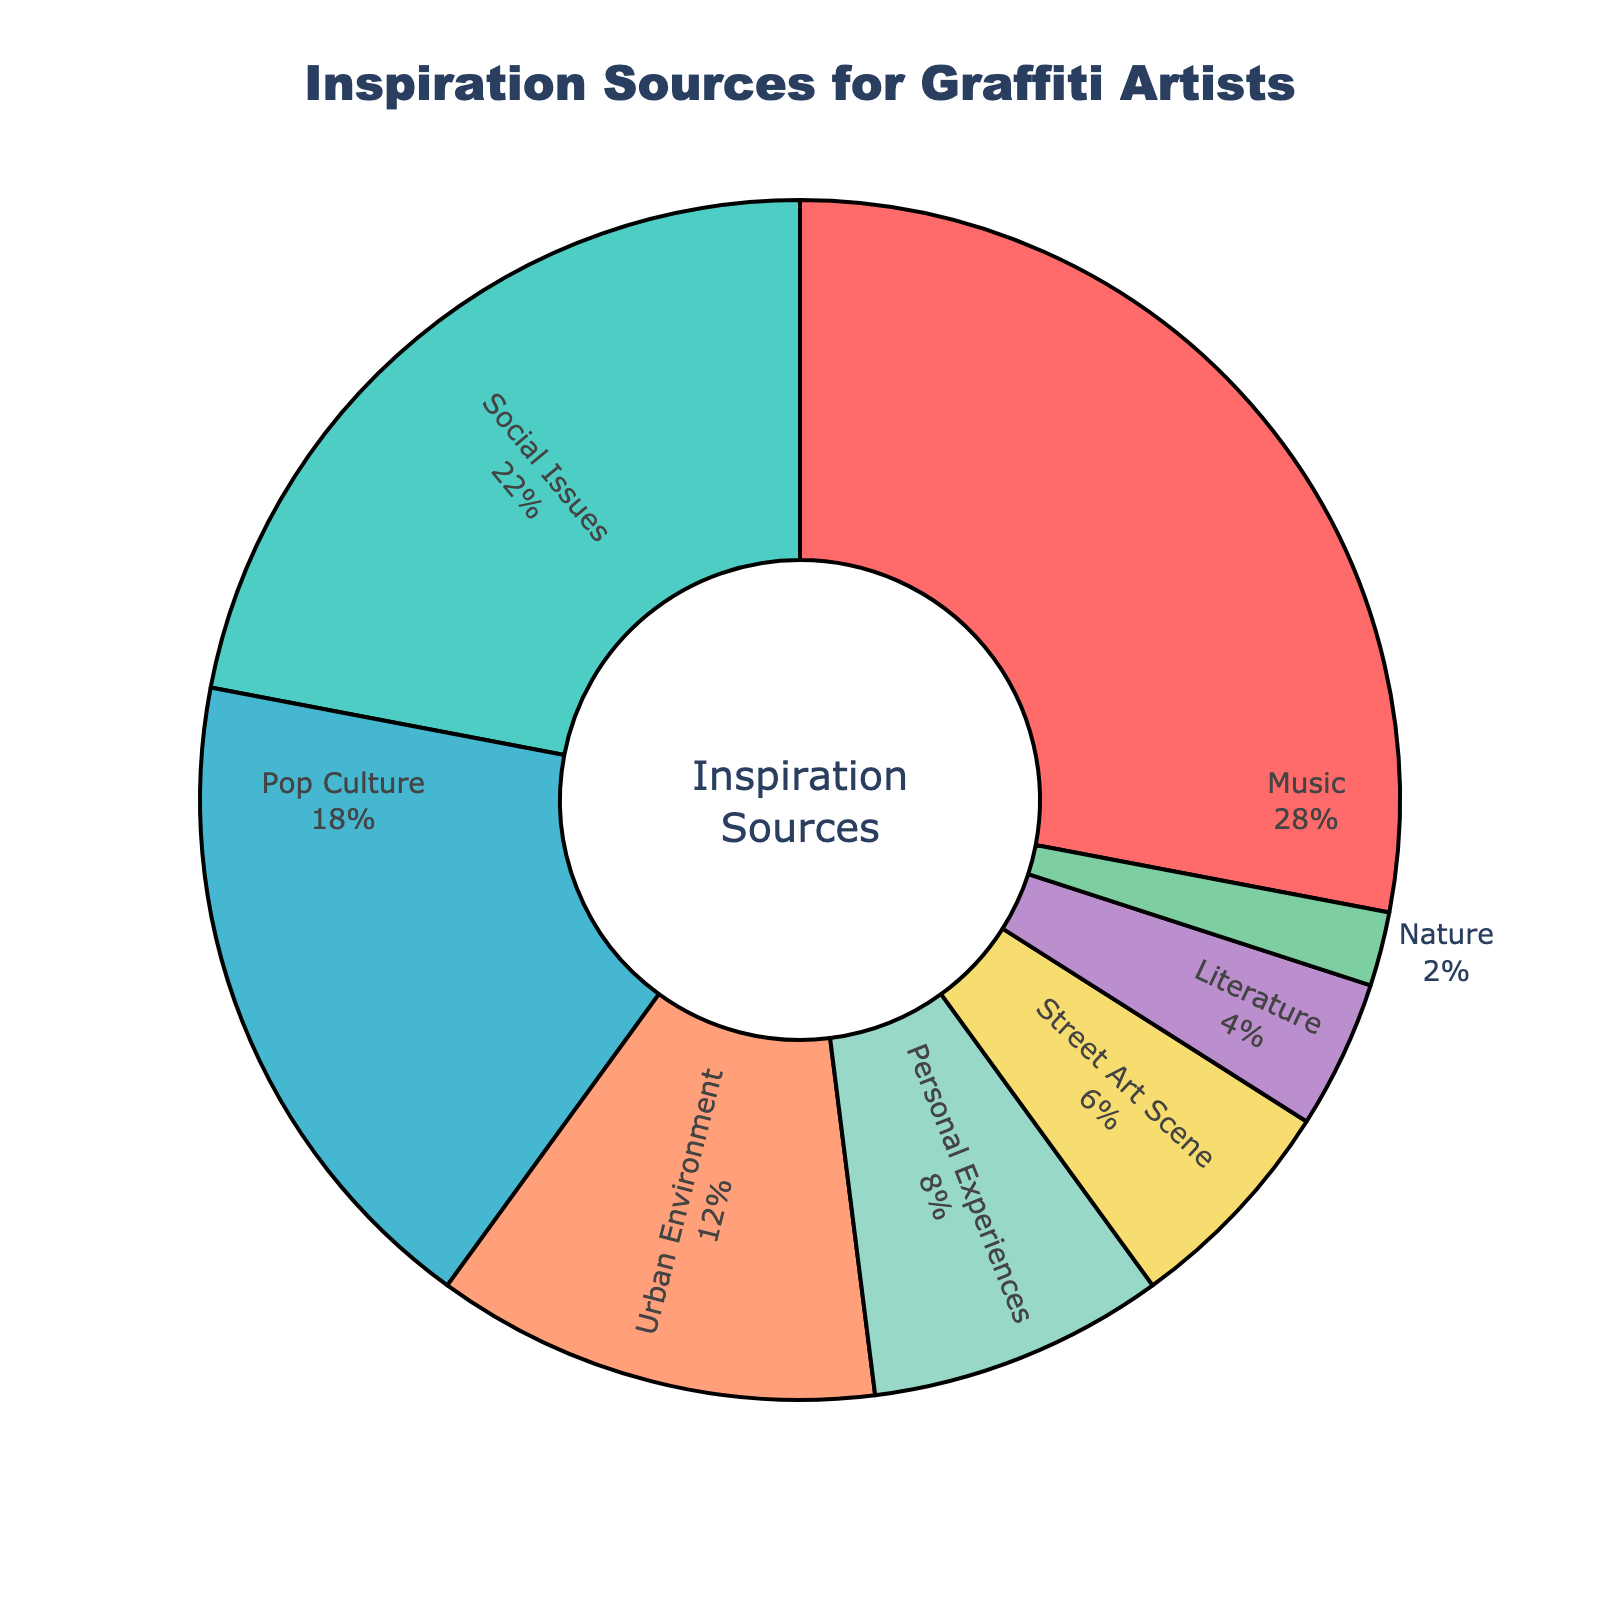What is the most common source of inspiration for graffiti artists? By looking at the pie chart, we can see which slice represents the largest percentage. The biggest slice is labeled "Music" with 28%.
Answer: Music Which two sources have the smallest percentages? By inspecting the pie chart, we can identify the smallest slices. "Nature" and "Literature" have the smallest slices with 2% and 4%, respectively.
Answer: Nature and Literature How much more percentage does 'Music' have compared to 'Social Issues'? The 'Music' slice is 28%, and the 'Social Issues' slice is 22%. The difference is calculated as 28% - 22% = 6%.
Answer: 6% What proportion of the inspiration comes from 'Urban Environment' and 'Personal Experiences' combined? Add up the percentages for 'Urban Environment' and 'Personal Experiences': 12% + 8% = 20%.
Answer: 20% Which inspiration source is represented by the dark green slice? From the visual attributes, the dark green slice is labeled 'Urban Environment' with 12%.
Answer: Urban Environment Between 'Street Art Scene' and 'Pop Culture', which one has a higher percentage and by how much? 'Pop Culture' stands at 18% while 'Street Art Scene' is 6%. The difference can be calculated as 18% - 6% = 12%.
Answer: Pop Culture by 12% What is the cumulative percentage of 'Music', 'Social Issues', and 'Pop Culture'? Adding the percentages for 'Music', 'Social Issues', and 'Pop Culture': 28% + 22% + 18% = 68%.
Answer: 68% Is 'Nature' a relatively significant source of inspiration compared to 'Literature'? 'Nature' is 2% while 'Literature' is 4%. 'Nature' is less significant by 2%.
Answer: No, it is less significant How much more combined percentage do ‘Music’ and ‘Social Issues’ have than the total of 'Street Art Scene' and 'Nature'? First, add the percentages: 'Music' + 'Social Issues' = 28% + 22% = 50%; 'Street Art Scene' + 'Nature' = 6% + 2% = 8%. Now, compute the difference: 50% - 8% = 42%.
Answer: 42% Which source is immediately following 'Pop Culture' in terms of inspiration percentage? Looking at the descending order in percentage, 'Urban Environment' follows 'Pop Culture' with 12%.
Answer: Urban Environment 